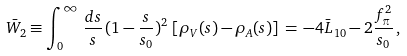<formula> <loc_0><loc_0><loc_500><loc_500>\bar { W } _ { 2 } \equiv \int _ { 0 } ^ { \infty } \, \frac { d s } { s } \, ( 1 - \frac { s } { s _ { 0 } } ) ^ { 2 } \, \left [ \rho _ { V } ( s ) - \rho _ { A } ( s ) \right ] \, = \, - 4 \bar { L } _ { 1 0 } - 2 \frac { f _ { \pi } ^ { 2 } } { s _ { 0 } } \, ,</formula> 